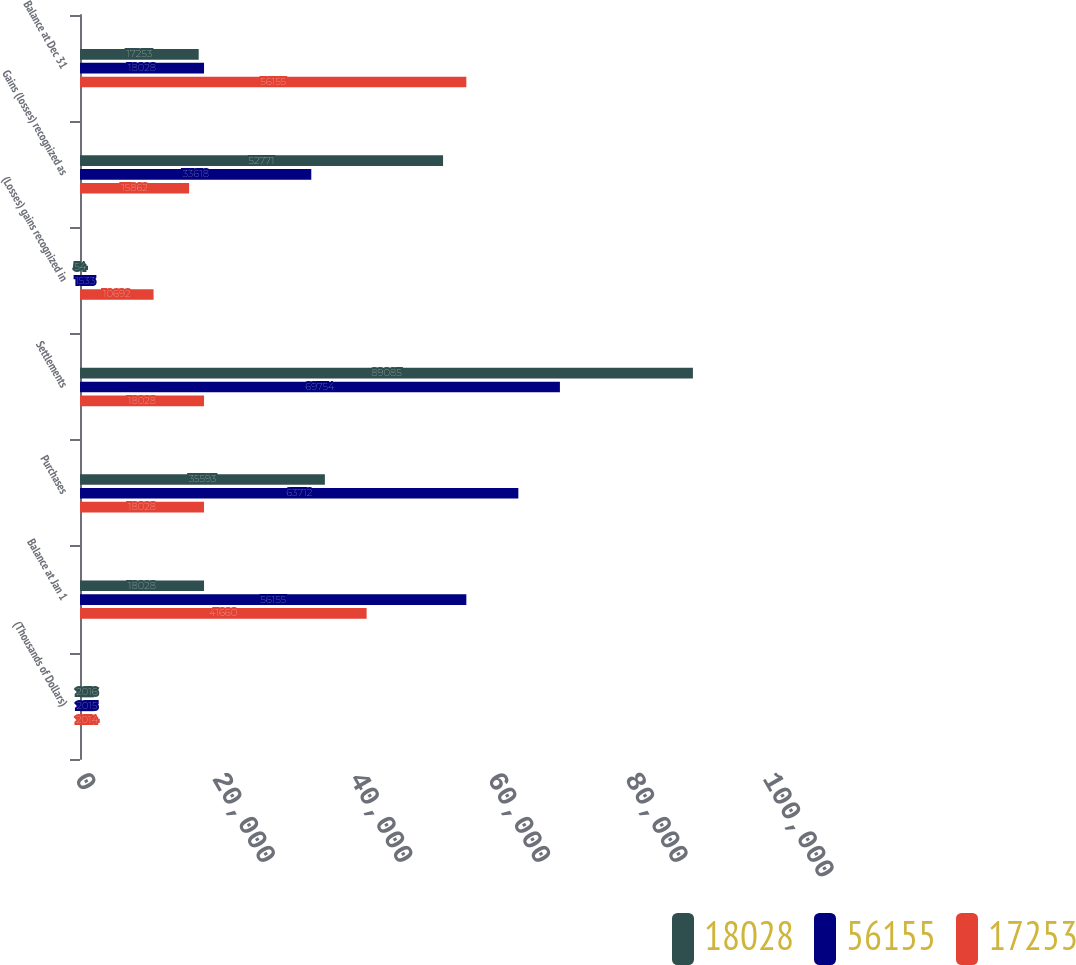Convert chart. <chart><loc_0><loc_0><loc_500><loc_500><stacked_bar_chart><ecel><fcel>(Thousands of Dollars)<fcel>Balance at Jan 1<fcel>Purchases<fcel>Settlements<fcel>(Losses) gains recognized in<fcel>Gains (losses) recognized as<fcel>Balance at Dec 31<nl><fcel>18028<fcel>2016<fcel>18028<fcel>35593<fcel>89085<fcel>54<fcel>52771<fcel>17253<nl><fcel>56155<fcel>2015<fcel>56155<fcel>63712<fcel>69754<fcel>1533<fcel>33618<fcel>18028<nl><fcel>17253<fcel>2014<fcel>41660<fcel>18028<fcel>18028<fcel>10692<fcel>15862<fcel>56155<nl></chart> 